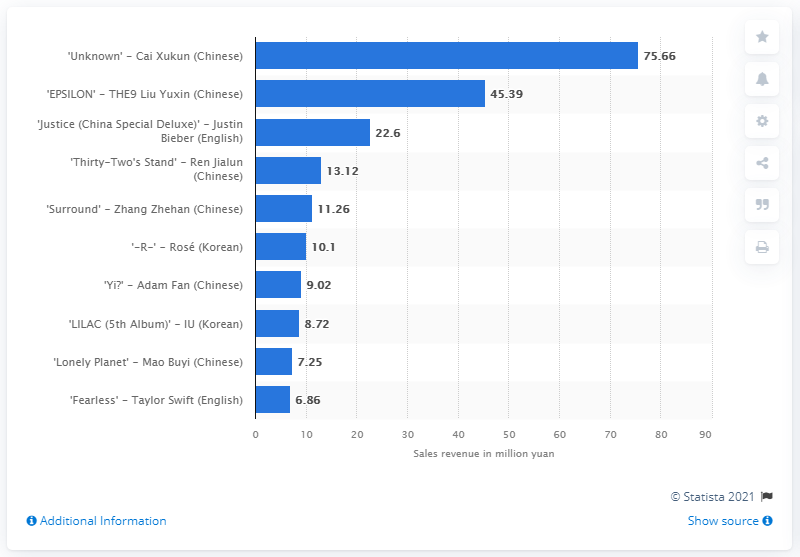Indicate a few pertinent items in this graphic. In 2021, the value of Justin Bieber's music album was 22.6 million dollars. 